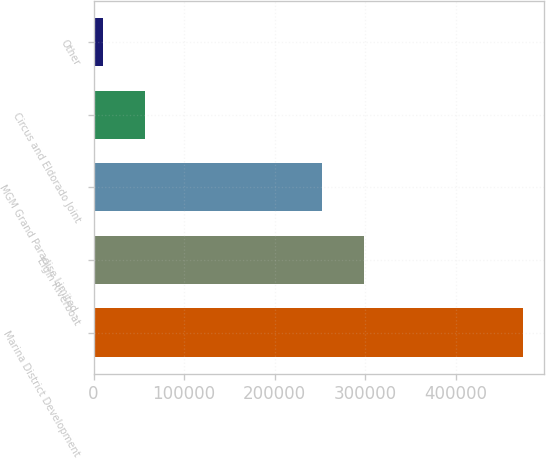<chart> <loc_0><loc_0><loc_500><loc_500><bar_chart><fcel>Marina District Development<fcel>Elgin Riverboat<fcel>MGM Grand Paradise Limited -<fcel>Circus and Eldorado Joint<fcel>Other<nl><fcel>474171<fcel>298398<fcel>252060<fcel>57126.3<fcel>10788<nl></chart> 